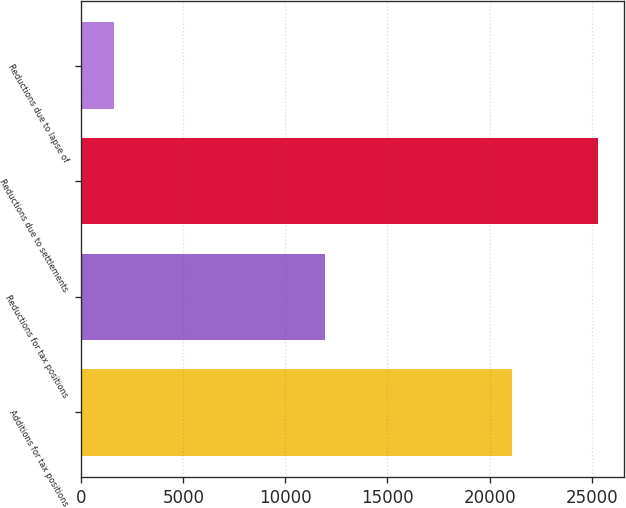Convert chart. <chart><loc_0><loc_0><loc_500><loc_500><bar_chart><fcel>Additions for tax positions<fcel>Reductions for tax positions<fcel>Reductions due to settlements<fcel>Reductions due to lapse of<nl><fcel>21099<fcel>11955<fcel>25294<fcel>1610<nl></chart> 